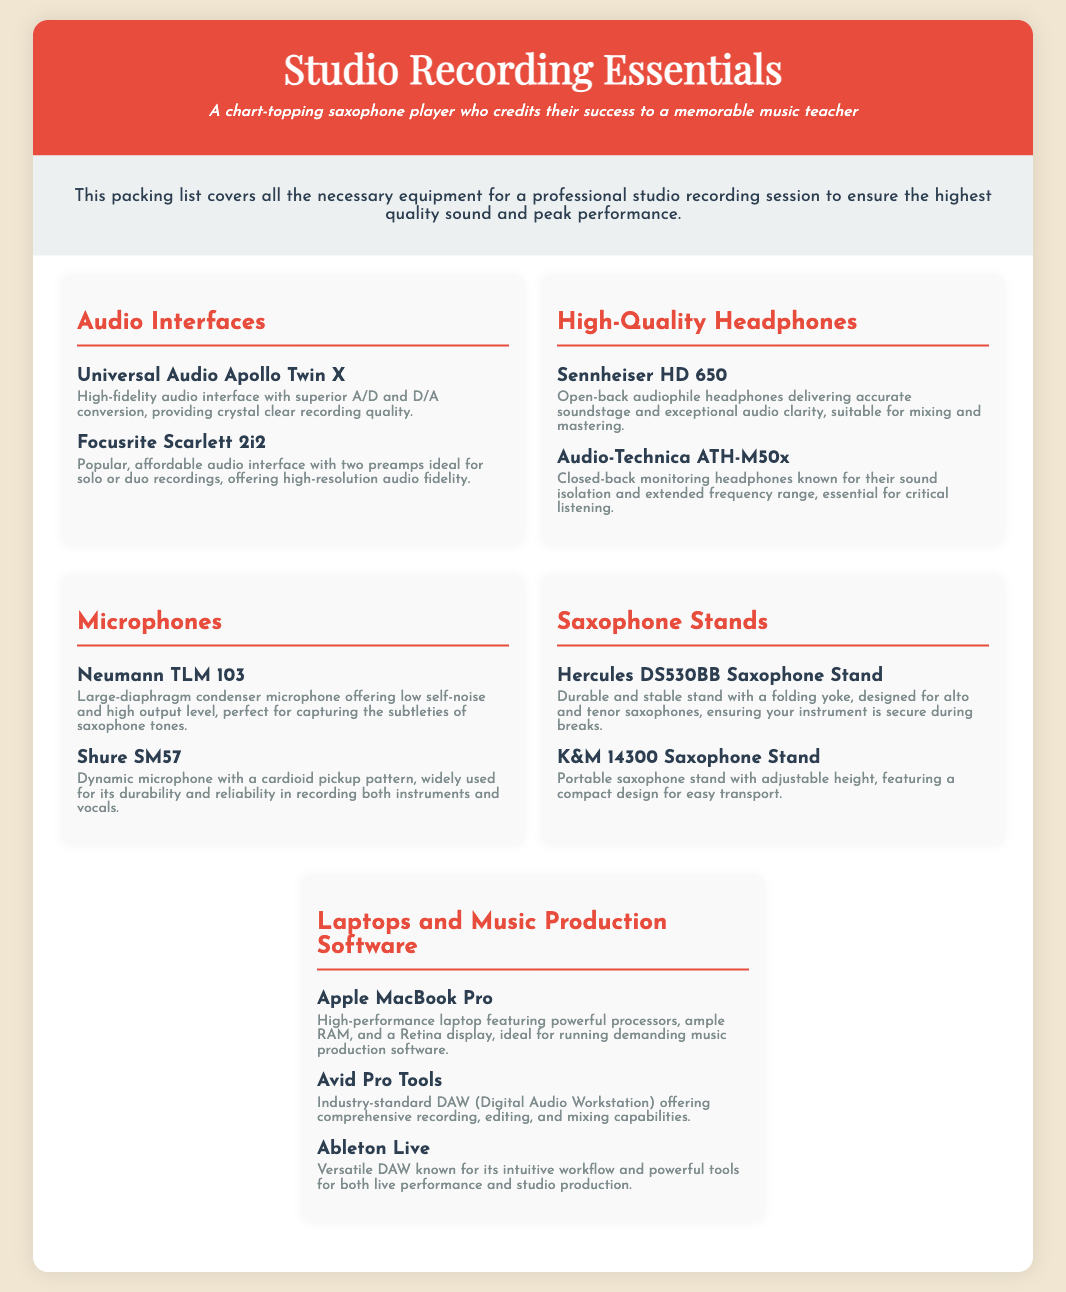What are the two audio interfaces listed? The document lists audio interfaces such as Universal Audio Apollo Twin X and Focusrite Scarlett 2i2.
Answer: Universal Audio Apollo Twin X, Focusrite Scarlett 2i2 Which headphones are known for sound isolation? The document states that Audio-Technica ATH-M50x are known for their sound isolation.
Answer: Audio-Technica ATH-M50x How many microphones are mentioned in the document? The document includes two microphones: Neumann TLM 103 and Shure SM57.
Answer: 2 What is the purpose of the Hercules DS530BB Saxophone Stand? The document describes that the Hercules DS530BB Saxophone Stand is designed to ensure the instrument is secure during breaks.
Answer: Secure the instrument Which laptop is mentioned as high-performance? The document mentions the Apple MacBook Pro as a high-performance laptop.
Answer: Apple MacBook Pro What does Avid Pro Tools offer according to the document? Avid Pro Tools offers comprehensive recording, editing, and mixing capabilities as stated in the document.
Answer: Comprehensive recording, editing, and mixing capabilities 